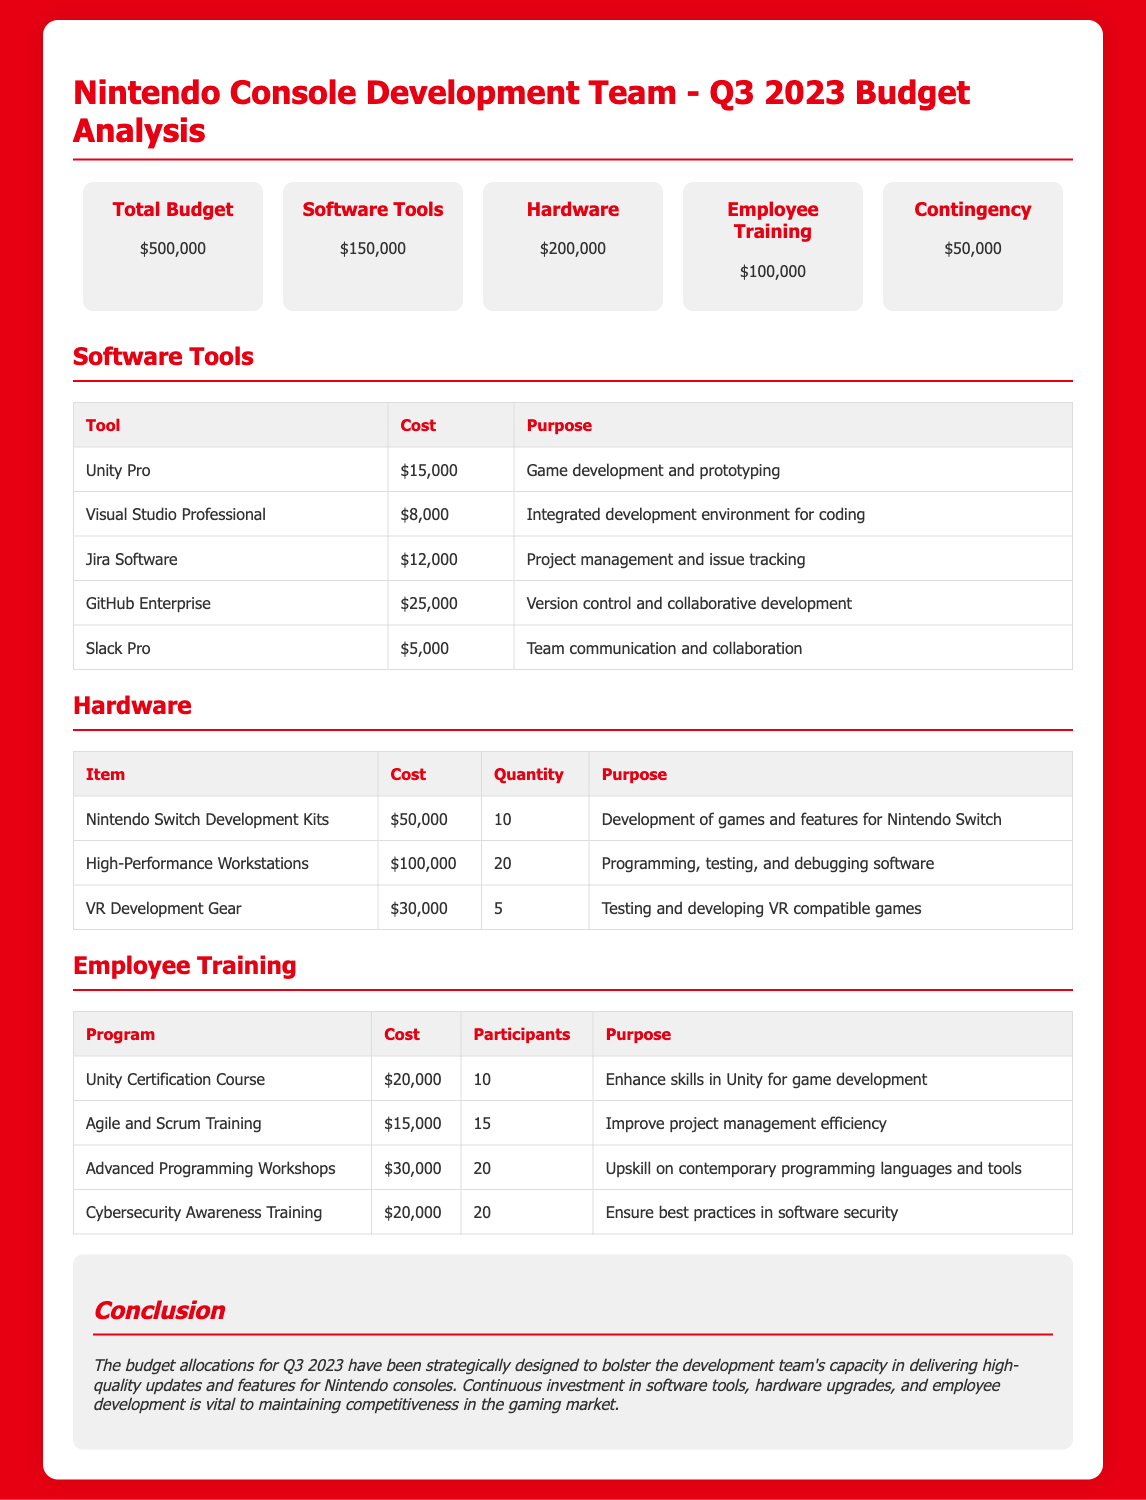what is the total budget for Q3 2023? The total budget is stated in the document's budget overview section, which shows a total of $500,000.
Answer: $500,000 how much is allocated for software tools? The budget overview specifies the allocation for software tools as $150,000.
Answer: $150,000 what is the cost of Unity Pro? The software tools table lists Unity Pro with a cost of $15,000.
Answer: $15,000 how many Nintendo Switch Development Kits are included in the budget? The hardware table details that 10 Nintendo Switch Development Kits are included in the expenses.
Answer: 10 what percentage of the total budget is dedicated to hardware? The hardware allocation ($200,000) is calculated as a percentage of the total budget ($500,000), resulting in 40%.
Answer: 40% how many employees are participating in the Advanced Programming Workshops? The employee training table indicates that 20 participants are enrolled in the Advanced Programming Workshops.
Answer: 20 what is the total cost for employee training programs? The total cost of the employee training programs can be summed from the table: $20,000 + $15,000 + $30,000 + $20,000 = $85,000.
Answer: $85,000 which software tool has the highest allocation? The software tools table shows that GitHub Enterprise has the highest allocation at $25,000.
Answer: GitHub Enterprise what is the purpose of Jira Software? The software tools table specifies that the purpose of Jira Software is project management and issue tracking.
Answer: Project management and issue tracking 